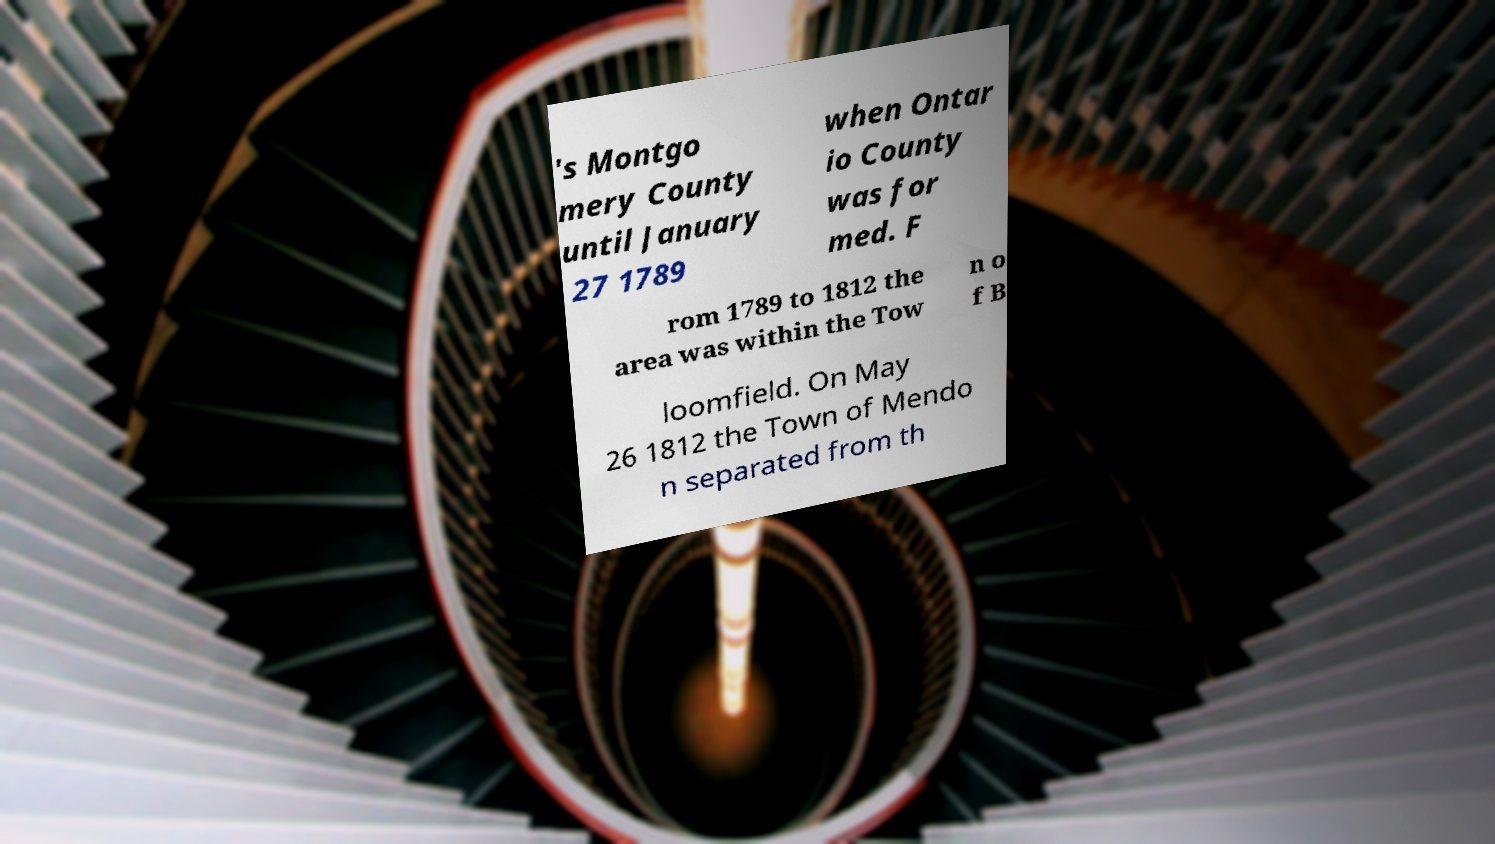Could you extract and type out the text from this image? 's Montgo mery County until January 27 1789 when Ontar io County was for med. F rom 1789 to 1812 the area was within the Tow n o f B loomfield. On May 26 1812 the Town of Mendo n separated from th 